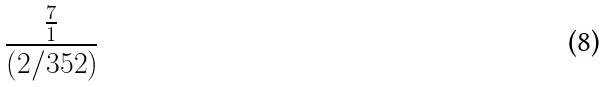<formula> <loc_0><loc_0><loc_500><loc_500>\frac { \frac { 7 } { 1 } } { ( 2 / 3 5 2 ) }</formula> 